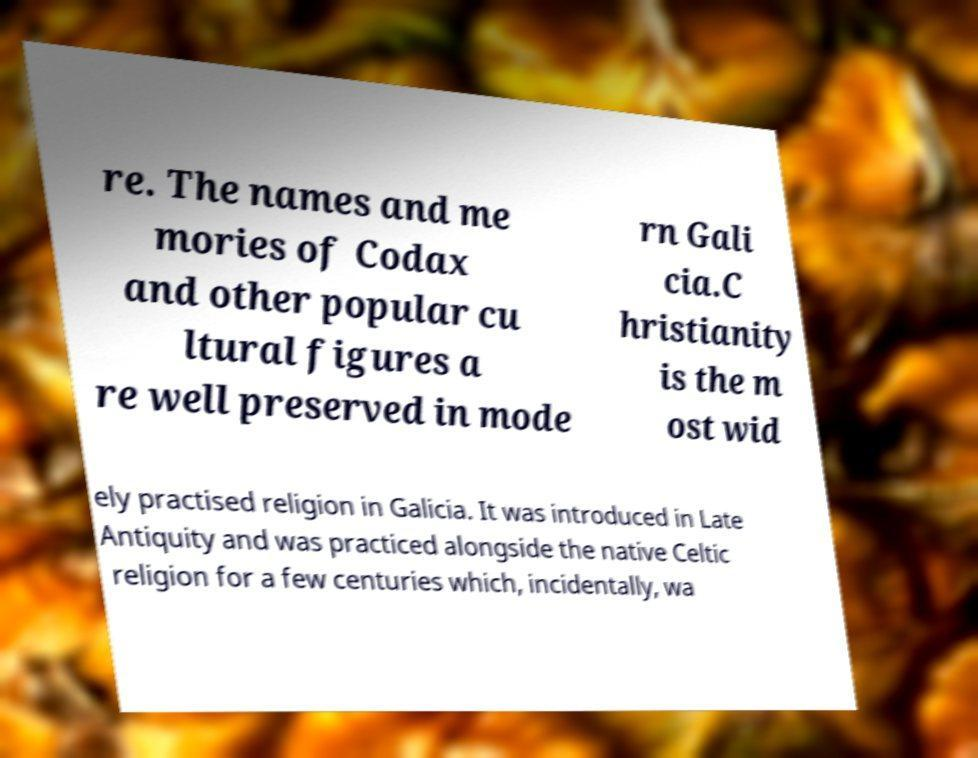Please read and relay the text visible in this image. What does it say? re. The names and me mories of Codax and other popular cu ltural figures a re well preserved in mode rn Gali cia.C hristianity is the m ost wid ely practised religion in Galicia. It was introduced in Late Antiquity and was practiced alongside the native Celtic religion for a few centuries which, incidentally, wa 